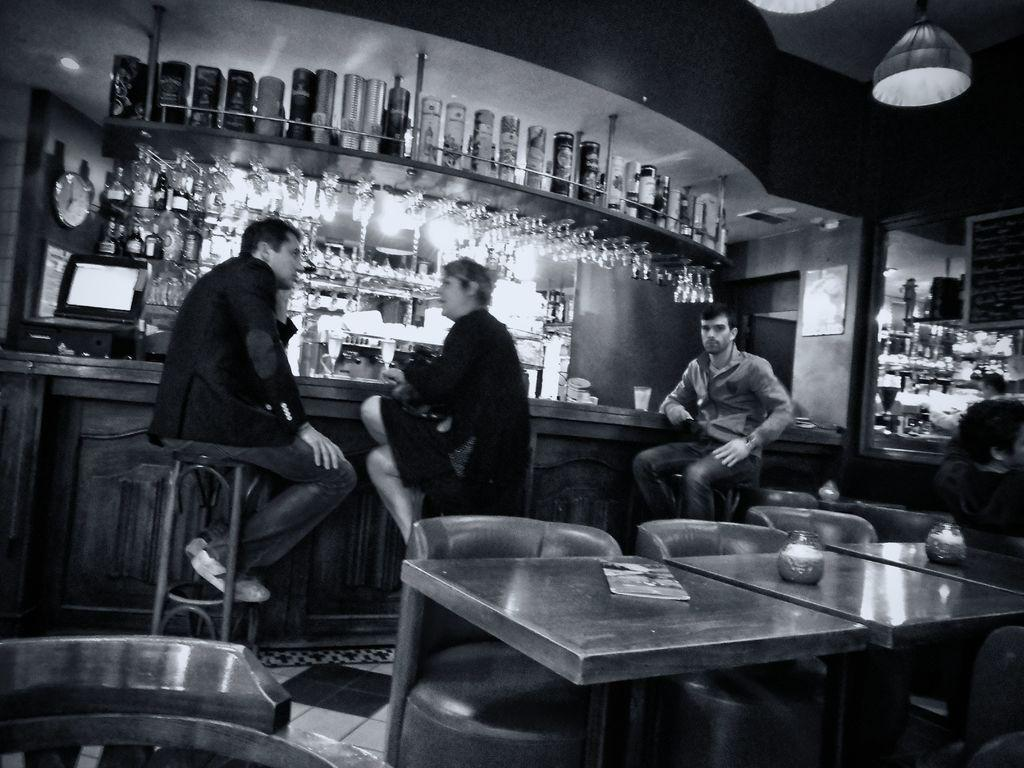How many people are sitting in the image? There are two men and a woman sitting in the image. What is present in the foreground of the image? There is a table in the image. What can be seen in the background of the image? There is a chair, bottles in a cupboard, a desk top, and a clock in the background of the image. What type of bean is being used to shade the woman's eyes in the image? There is no bean present in the image, nor is there any indication that the woman's eyes are being shaded. 